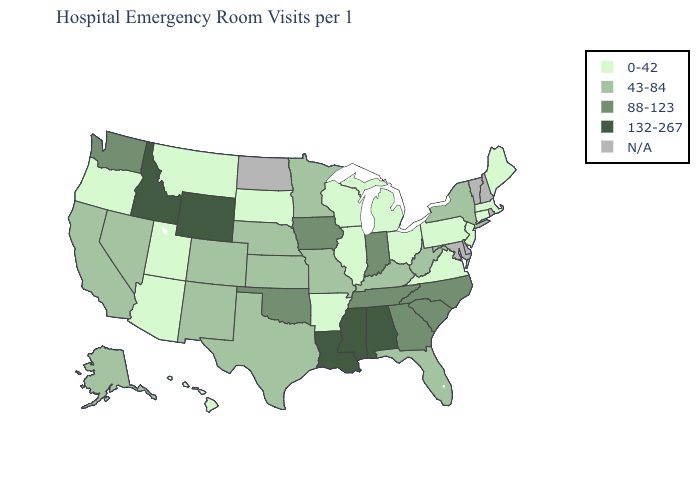Name the states that have a value in the range 88-123?
Answer briefly. Georgia, Indiana, Iowa, North Carolina, Oklahoma, South Carolina, Tennessee, Washington. Name the states that have a value in the range 132-267?
Quick response, please. Alabama, Idaho, Louisiana, Mississippi, Wyoming. Which states hav the highest value in the Northeast?
Answer briefly. New York. Name the states that have a value in the range 0-42?
Short answer required. Arizona, Arkansas, Connecticut, Hawaii, Illinois, Maine, Massachusetts, Michigan, Montana, New Jersey, Ohio, Oregon, Pennsylvania, South Dakota, Utah, Virginia, Wisconsin. What is the value of North Dakota?
Be succinct. N/A. Which states have the highest value in the USA?
Keep it brief. Alabama, Idaho, Louisiana, Mississippi, Wyoming. Which states have the lowest value in the West?
Answer briefly. Arizona, Hawaii, Montana, Oregon, Utah. Which states have the lowest value in the USA?
Be succinct. Arizona, Arkansas, Connecticut, Hawaii, Illinois, Maine, Massachusetts, Michigan, Montana, New Jersey, Ohio, Oregon, Pennsylvania, South Dakota, Utah, Virginia, Wisconsin. Does New York have the highest value in the Northeast?
Quick response, please. Yes. How many symbols are there in the legend?
Quick response, please. 5. Name the states that have a value in the range 132-267?
Keep it brief. Alabama, Idaho, Louisiana, Mississippi, Wyoming. What is the lowest value in states that border Minnesota?
Short answer required. 0-42. Name the states that have a value in the range 88-123?
Write a very short answer. Georgia, Indiana, Iowa, North Carolina, Oklahoma, South Carolina, Tennessee, Washington. What is the value of Indiana?
Short answer required. 88-123. 